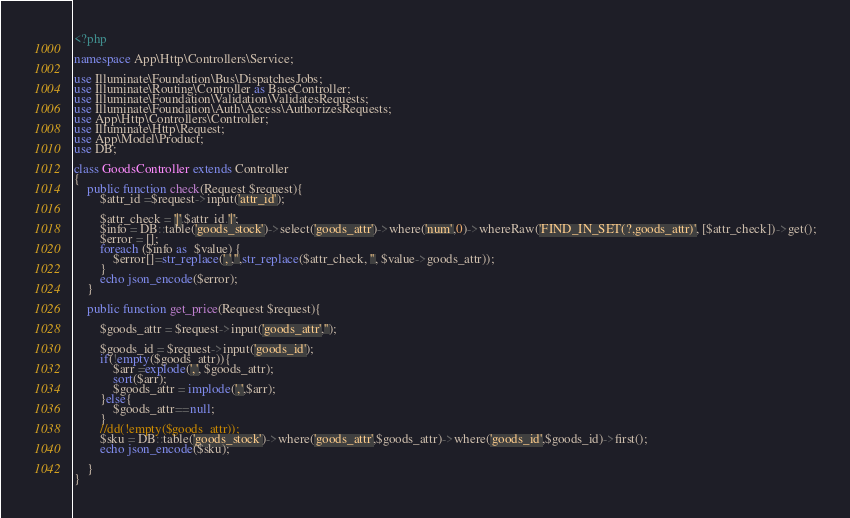<code> <loc_0><loc_0><loc_500><loc_500><_PHP_><?php

namespace App\Http\Controllers\Service;

use Illuminate\Foundation\Bus\DispatchesJobs;
use Illuminate\Routing\Controller as BaseController;
use Illuminate\Foundation\Validation\ValidatesRequests;
use Illuminate\Foundation\Auth\Access\AuthorizesRequests;
use App\Http\Controllers\Controller;
use Illuminate\Http\Request;
use App\Model\Product;
use DB;

class GoodsController extends Controller
{
	public function check(Request $request){
		$attr_id =$request->input('attr_id');
		
		$attr_check = '|'.$attr_id.'|';
		$info = DB::table('goods_stock')->select('goods_attr')->where('num',0)->whereRaw('FIND_IN_SET(?,goods_attr)', [$attr_check])->get();
		$error = [];
		foreach ($info as  $value) {
			$error[]=str_replace(',','',str_replace($attr_check, '', $value->goods_attr));
		}
		echo json_encode($error);
	}
	
	public function get_price(Request $request){
	
		$goods_attr = $request->input('goods_attr','');
		
		$goods_id = $request->input('goods_id');
		if(!empty($goods_attr)){
			$arr =explode(',', $goods_attr);
			sort($arr);
			$goods_attr = implode(',',$arr);
		}else{
			$goods_attr==null;
		}
		//dd(!empty($goods_attr));
		$sku = DB::table('goods_stock')->where('goods_attr',$goods_attr)->where('goods_id',$goods_id)->first();
		echo json_encode($sku);	
	
	}
}
</code> 